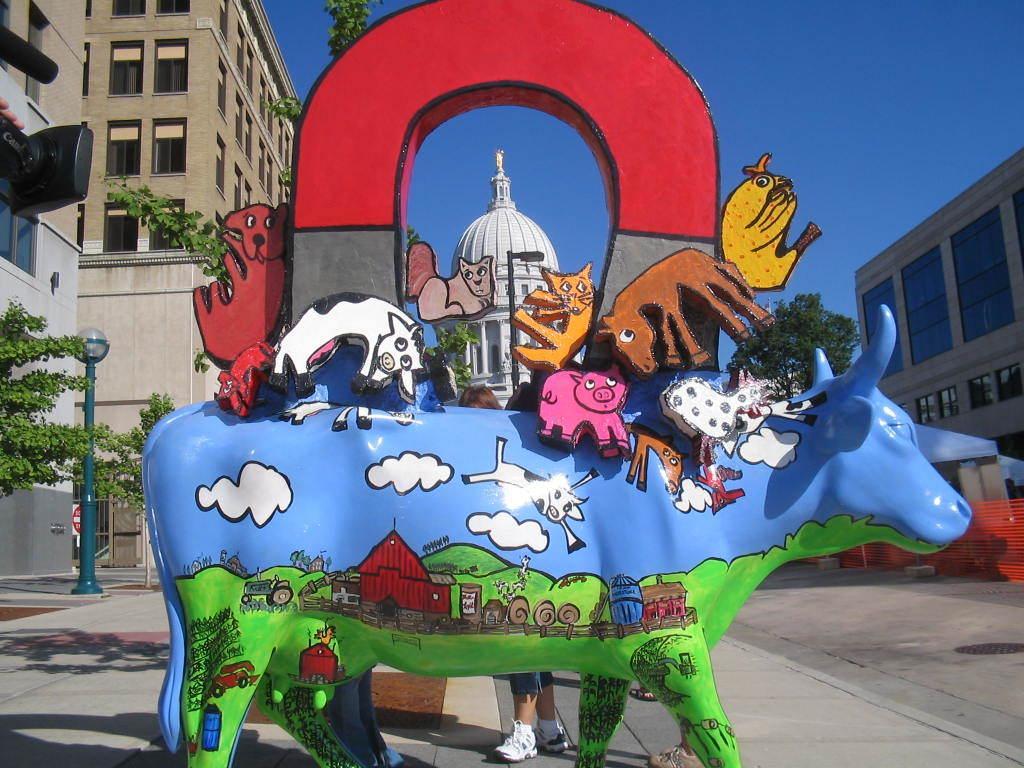Could you give a brief overview of what you see in this image? In the center of the image we can see a sculpture. In the background there are buildings, trees, pole and sky. At the bottom there is a road. 